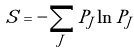Convert formula to latex. <formula><loc_0><loc_0><loc_500><loc_500>S = - \sum _ { J } P _ { J } \ln P _ { J }</formula> 